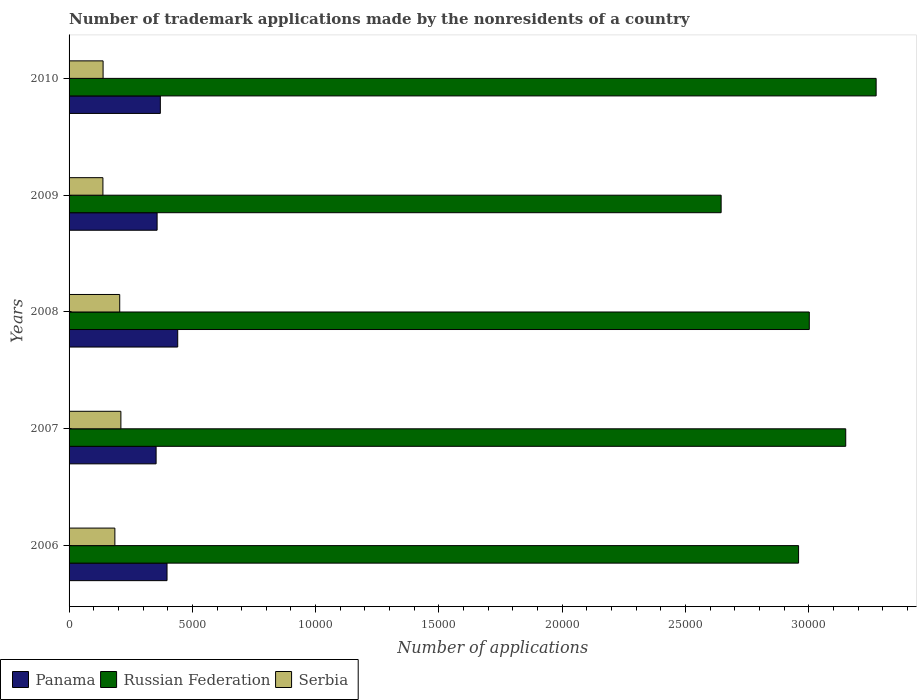Are the number of bars on each tick of the Y-axis equal?
Offer a terse response. Yes. How many bars are there on the 2nd tick from the bottom?
Give a very brief answer. 3. What is the label of the 4th group of bars from the top?
Your answer should be very brief. 2007. What is the number of trademark applications made by the nonresidents in Serbia in 2006?
Provide a succinct answer. 1858. Across all years, what is the maximum number of trademark applications made by the nonresidents in Panama?
Your response must be concise. 4407. Across all years, what is the minimum number of trademark applications made by the nonresidents in Russian Federation?
Offer a terse response. 2.64e+04. What is the total number of trademark applications made by the nonresidents in Panama in the graph?
Give a very brief answer. 1.92e+04. What is the difference between the number of trademark applications made by the nonresidents in Panama in 2007 and that in 2009?
Your answer should be very brief. -41. What is the difference between the number of trademark applications made by the nonresidents in Panama in 2009 and the number of trademark applications made by the nonresidents in Russian Federation in 2007?
Ensure brevity in your answer.  -2.79e+04. What is the average number of trademark applications made by the nonresidents in Serbia per year?
Your response must be concise. 1753.4. In the year 2010, what is the difference between the number of trademark applications made by the nonresidents in Russian Federation and number of trademark applications made by the nonresidents in Panama?
Your answer should be compact. 2.90e+04. In how many years, is the number of trademark applications made by the nonresidents in Panama greater than 5000 ?
Ensure brevity in your answer.  0. What is the ratio of the number of trademark applications made by the nonresidents in Russian Federation in 2006 to that in 2007?
Keep it short and to the point. 0.94. What is the difference between the highest and the second highest number of trademark applications made by the nonresidents in Panama?
Ensure brevity in your answer.  434. What is the difference between the highest and the lowest number of trademark applications made by the nonresidents in Panama?
Ensure brevity in your answer.  877. In how many years, is the number of trademark applications made by the nonresidents in Russian Federation greater than the average number of trademark applications made by the nonresidents in Russian Federation taken over all years?
Your response must be concise. 2. What does the 2nd bar from the top in 2006 represents?
Offer a very short reply. Russian Federation. What does the 1st bar from the bottom in 2009 represents?
Give a very brief answer. Panama. Is it the case that in every year, the sum of the number of trademark applications made by the nonresidents in Russian Federation and number of trademark applications made by the nonresidents in Serbia is greater than the number of trademark applications made by the nonresidents in Panama?
Your answer should be very brief. Yes. How many bars are there?
Provide a succinct answer. 15. Are all the bars in the graph horizontal?
Ensure brevity in your answer.  Yes. Does the graph contain grids?
Your response must be concise. No. Where does the legend appear in the graph?
Your response must be concise. Bottom left. How many legend labels are there?
Keep it short and to the point. 3. How are the legend labels stacked?
Your response must be concise. Horizontal. What is the title of the graph?
Your response must be concise. Number of trademark applications made by the nonresidents of a country. What is the label or title of the X-axis?
Provide a short and direct response. Number of applications. What is the Number of applications of Panama in 2006?
Your answer should be very brief. 3973. What is the Number of applications of Russian Federation in 2006?
Your answer should be very brief. 2.96e+04. What is the Number of applications of Serbia in 2006?
Keep it short and to the point. 1858. What is the Number of applications in Panama in 2007?
Offer a very short reply. 3530. What is the Number of applications of Russian Federation in 2007?
Your answer should be compact. 3.15e+04. What is the Number of applications in Serbia in 2007?
Your answer should be very brief. 2102. What is the Number of applications in Panama in 2008?
Provide a short and direct response. 4407. What is the Number of applications of Russian Federation in 2008?
Keep it short and to the point. 3.00e+04. What is the Number of applications in Serbia in 2008?
Your response must be concise. 2054. What is the Number of applications in Panama in 2009?
Provide a succinct answer. 3571. What is the Number of applications in Russian Federation in 2009?
Provide a short and direct response. 2.64e+04. What is the Number of applications in Serbia in 2009?
Your response must be concise. 1373. What is the Number of applications of Panama in 2010?
Your answer should be compact. 3702. What is the Number of applications of Russian Federation in 2010?
Offer a terse response. 3.27e+04. What is the Number of applications of Serbia in 2010?
Offer a terse response. 1380. Across all years, what is the maximum Number of applications of Panama?
Provide a succinct answer. 4407. Across all years, what is the maximum Number of applications of Russian Federation?
Provide a succinct answer. 3.27e+04. Across all years, what is the maximum Number of applications of Serbia?
Your answer should be very brief. 2102. Across all years, what is the minimum Number of applications in Panama?
Give a very brief answer. 3530. Across all years, what is the minimum Number of applications in Russian Federation?
Offer a very short reply. 2.64e+04. Across all years, what is the minimum Number of applications of Serbia?
Provide a succinct answer. 1373. What is the total Number of applications of Panama in the graph?
Your answer should be compact. 1.92e+04. What is the total Number of applications of Russian Federation in the graph?
Your response must be concise. 1.50e+05. What is the total Number of applications of Serbia in the graph?
Provide a short and direct response. 8767. What is the difference between the Number of applications in Panama in 2006 and that in 2007?
Give a very brief answer. 443. What is the difference between the Number of applications of Russian Federation in 2006 and that in 2007?
Provide a short and direct response. -1913. What is the difference between the Number of applications in Serbia in 2006 and that in 2007?
Your answer should be compact. -244. What is the difference between the Number of applications in Panama in 2006 and that in 2008?
Keep it short and to the point. -434. What is the difference between the Number of applications in Russian Federation in 2006 and that in 2008?
Your answer should be compact. -435. What is the difference between the Number of applications of Serbia in 2006 and that in 2008?
Your answer should be very brief. -196. What is the difference between the Number of applications of Panama in 2006 and that in 2009?
Keep it short and to the point. 402. What is the difference between the Number of applications of Russian Federation in 2006 and that in 2009?
Keep it short and to the point. 3141. What is the difference between the Number of applications in Serbia in 2006 and that in 2009?
Provide a short and direct response. 485. What is the difference between the Number of applications in Panama in 2006 and that in 2010?
Give a very brief answer. 271. What is the difference between the Number of applications in Russian Federation in 2006 and that in 2010?
Your answer should be compact. -3146. What is the difference between the Number of applications of Serbia in 2006 and that in 2010?
Provide a succinct answer. 478. What is the difference between the Number of applications of Panama in 2007 and that in 2008?
Ensure brevity in your answer.  -877. What is the difference between the Number of applications of Russian Federation in 2007 and that in 2008?
Your answer should be compact. 1478. What is the difference between the Number of applications in Serbia in 2007 and that in 2008?
Make the answer very short. 48. What is the difference between the Number of applications in Panama in 2007 and that in 2009?
Make the answer very short. -41. What is the difference between the Number of applications in Russian Federation in 2007 and that in 2009?
Your answer should be very brief. 5054. What is the difference between the Number of applications of Serbia in 2007 and that in 2009?
Make the answer very short. 729. What is the difference between the Number of applications in Panama in 2007 and that in 2010?
Offer a very short reply. -172. What is the difference between the Number of applications in Russian Federation in 2007 and that in 2010?
Offer a terse response. -1233. What is the difference between the Number of applications of Serbia in 2007 and that in 2010?
Offer a very short reply. 722. What is the difference between the Number of applications of Panama in 2008 and that in 2009?
Make the answer very short. 836. What is the difference between the Number of applications of Russian Federation in 2008 and that in 2009?
Offer a very short reply. 3576. What is the difference between the Number of applications in Serbia in 2008 and that in 2009?
Ensure brevity in your answer.  681. What is the difference between the Number of applications in Panama in 2008 and that in 2010?
Your answer should be compact. 705. What is the difference between the Number of applications in Russian Federation in 2008 and that in 2010?
Ensure brevity in your answer.  -2711. What is the difference between the Number of applications of Serbia in 2008 and that in 2010?
Make the answer very short. 674. What is the difference between the Number of applications of Panama in 2009 and that in 2010?
Your answer should be very brief. -131. What is the difference between the Number of applications of Russian Federation in 2009 and that in 2010?
Offer a very short reply. -6287. What is the difference between the Number of applications of Panama in 2006 and the Number of applications of Russian Federation in 2007?
Offer a terse response. -2.75e+04. What is the difference between the Number of applications of Panama in 2006 and the Number of applications of Serbia in 2007?
Offer a very short reply. 1871. What is the difference between the Number of applications in Russian Federation in 2006 and the Number of applications in Serbia in 2007?
Keep it short and to the point. 2.75e+04. What is the difference between the Number of applications of Panama in 2006 and the Number of applications of Russian Federation in 2008?
Provide a succinct answer. -2.61e+04. What is the difference between the Number of applications in Panama in 2006 and the Number of applications in Serbia in 2008?
Make the answer very short. 1919. What is the difference between the Number of applications in Russian Federation in 2006 and the Number of applications in Serbia in 2008?
Provide a succinct answer. 2.75e+04. What is the difference between the Number of applications in Panama in 2006 and the Number of applications in Russian Federation in 2009?
Keep it short and to the point. -2.25e+04. What is the difference between the Number of applications in Panama in 2006 and the Number of applications in Serbia in 2009?
Keep it short and to the point. 2600. What is the difference between the Number of applications of Russian Federation in 2006 and the Number of applications of Serbia in 2009?
Your answer should be very brief. 2.82e+04. What is the difference between the Number of applications in Panama in 2006 and the Number of applications in Russian Federation in 2010?
Keep it short and to the point. -2.88e+04. What is the difference between the Number of applications in Panama in 2006 and the Number of applications in Serbia in 2010?
Offer a terse response. 2593. What is the difference between the Number of applications in Russian Federation in 2006 and the Number of applications in Serbia in 2010?
Offer a terse response. 2.82e+04. What is the difference between the Number of applications of Panama in 2007 and the Number of applications of Russian Federation in 2008?
Provide a succinct answer. -2.65e+04. What is the difference between the Number of applications of Panama in 2007 and the Number of applications of Serbia in 2008?
Offer a terse response. 1476. What is the difference between the Number of applications of Russian Federation in 2007 and the Number of applications of Serbia in 2008?
Your response must be concise. 2.94e+04. What is the difference between the Number of applications in Panama in 2007 and the Number of applications in Russian Federation in 2009?
Give a very brief answer. -2.29e+04. What is the difference between the Number of applications of Panama in 2007 and the Number of applications of Serbia in 2009?
Your response must be concise. 2157. What is the difference between the Number of applications in Russian Federation in 2007 and the Number of applications in Serbia in 2009?
Offer a terse response. 3.01e+04. What is the difference between the Number of applications of Panama in 2007 and the Number of applications of Russian Federation in 2010?
Ensure brevity in your answer.  -2.92e+04. What is the difference between the Number of applications of Panama in 2007 and the Number of applications of Serbia in 2010?
Provide a short and direct response. 2150. What is the difference between the Number of applications in Russian Federation in 2007 and the Number of applications in Serbia in 2010?
Your answer should be very brief. 3.01e+04. What is the difference between the Number of applications of Panama in 2008 and the Number of applications of Russian Federation in 2009?
Keep it short and to the point. -2.20e+04. What is the difference between the Number of applications in Panama in 2008 and the Number of applications in Serbia in 2009?
Provide a succinct answer. 3034. What is the difference between the Number of applications of Russian Federation in 2008 and the Number of applications of Serbia in 2009?
Your response must be concise. 2.87e+04. What is the difference between the Number of applications of Panama in 2008 and the Number of applications of Russian Federation in 2010?
Offer a terse response. -2.83e+04. What is the difference between the Number of applications of Panama in 2008 and the Number of applications of Serbia in 2010?
Your response must be concise. 3027. What is the difference between the Number of applications of Russian Federation in 2008 and the Number of applications of Serbia in 2010?
Ensure brevity in your answer.  2.86e+04. What is the difference between the Number of applications of Panama in 2009 and the Number of applications of Russian Federation in 2010?
Keep it short and to the point. -2.92e+04. What is the difference between the Number of applications of Panama in 2009 and the Number of applications of Serbia in 2010?
Give a very brief answer. 2191. What is the difference between the Number of applications in Russian Federation in 2009 and the Number of applications in Serbia in 2010?
Offer a terse response. 2.51e+04. What is the average Number of applications in Panama per year?
Make the answer very short. 3836.6. What is the average Number of applications in Russian Federation per year?
Provide a short and direct response. 3.01e+04. What is the average Number of applications of Serbia per year?
Provide a short and direct response. 1753.4. In the year 2006, what is the difference between the Number of applications in Panama and Number of applications in Russian Federation?
Give a very brief answer. -2.56e+04. In the year 2006, what is the difference between the Number of applications of Panama and Number of applications of Serbia?
Keep it short and to the point. 2115. In the year 2006, what is the difference between the Number of applications of Russian Federation and Number of applications of Serbia?
Offer a very short reply. 2.77e+04. In the year 2007, what is the difference between the Number of applications in Panama and Number of applications in Russian Federation?
Give a very brief answer. -2.80e+04. In the year 2007, what is the difference between the Number of applications in Panama and Number of applications in Serbia?
Your response must be concise. 1428. In the year 2007, what is the difference between the Number of applications in Russian Federation and Number of applications in Serbia?
Provide a short and direct response. 2.94e+04. In the year 2008, what is the difference between the Number of applications in Panama and Number of applications in Russian Federation?
Your answer should be very brief. -2.56e+04. In the year 2008, what is the difference between the Number of applications in Panama and Number of applications in Serbia?
Offer a very short reply. 2353. In the year 2008, what is the difference between the Number of applications of Russian Federation and Number of applications of Serbia?
Your response must be concise. 2.80e+04. In the year 2009, what is the difference between the Number of applications of Panama and Number of applications of Russian Federation?
Your response must be concise. -2.29e+04. In the year 2009, what is the difference between the Number of applications of Panama and Number of applications of Serbia?
Make the answer very short. 2198. In the year 2009, what is the difference between the Number of applications of Russian Federation and Number of applications of Serbia?
Keep it short and to the point. 2.51e+04. In the year 2010, what is the difference between the Number of applications in Panama and Number of applications in Russian Federation?
Your response must be concise. -2.90e+04. In the year 2010, what is the difference between the Number of applications of Panama and Number of applications of Serbia?
Make the answer very short. 2322. In the year 2010, what is the difference between the Number of applications of Russian Federation and Number of applications of Serbia?
Keep it short and to the point. 3.14e+04. What is the ratio of the Number of applications of Panama in 2006 to that in 2007?
Offer a very short reply. 1.13. What is the ratio of the Number of applications in Russian Federation in 2006 to that in 2007?
Provide a short and direct response. 0.94. What is the ratio of the Number of applications in Serbia in 2006 to that in 2007?
Provide a succinct answer. 0.88. What is the ratio of the Number of applications of Panama in 2006 to that in 2008?
Ensure brevity in your answer.  0.9. What is the ratio of the Number of applications in Russian Federation in 2006 to that in 2008?
Your response must be concise. 0.99. What is the ratio of the Number of applications in Serbia in 2006 to that in 2008?
Your answer should be very brief. 0.9. What is the ratio of the Number of applications of Panama in 2006 to that in 2009?
Your answer should be compact. 1.11. What is the ratio of the Number of applications in Russian Federation in 2006 to that in 2009?
Keep it short and to the point. 1.12. What is the ratio of the Number of applications in Serbia in 2006 to that in 2009?
Provide a short and direct response. 1.35. What is the ratio of the Number of applications of Panama in 2006 to that in 2010?
Give a very brief answer. 1.07. What is the ratio of the Number of applications in Russian Federation in 2006 to that in 2010?
Offer a terse response. 0.9. What is the ratio of the Number of applications in Serbia in 2006 to that in 2010?
Ensure brevity in your answer.  1.35. What is the ratio of the Number of applications in Panama in 2007 to that in 2008?
Make the answer very short. 0.8. What is the ratio of the Number of applications in Russian Federation in 2007 to that in 2008?
Keep it short and to the point. 1.05. What is the ratio of the Number of applications of Serbia in 2007 to that in 2008?
Provide a short and direct response. 1.02. What is the ratio of the Number of applications in Russian Federation in 2007 to that in 2009?
Provide a short and direct response. 1.19. What is the ratio of the Number of applications in Serbia in 2007 to that in 2009?
Your answer should be compact. 1.53. What is the ratio of the Number of applications in Panama in 2007 to that in 2010?
Offer a very short reply. 0.95. What is the ratio of the Number of applications in Russian Federation in 2007 to that in 2010?
Offer a very short reply. 0.96. What is the ratio of the Number of applications in Serbia in 2007 to that in 2010?
Ensure brevity in your answer.  1.52. What is the ratio of the Number of applications in Panama in 2008 to that in 2009?
Provide a succinct answer. 1.23. What is the ratio of the Number of applications in Russian Federation in 2008 to that in 2009?
Ensure brevity in your answer.  1.14. What is the ratio of the Number of applications of Serbia in 2008 to that in 2009?
Your answer should be very brief. 1.5. What is the ratio of the Number of applications of Panama in 2008 to that in 2010?
Give a very brief answer. 1.19. What is the ratio of the Number of applications in Russian Federation in 2008 to that in 2010?
Offer a terse response. 0.92. What is the ratio of the Number of applications of Serbia in 2008 to that in 2010?
Your answer should be compact. 1.49. What is the ratio of the Number of applications in Panama in 2009 to that in 2010?
Your answer should be very brief. 0.96. What is the ratio of the Number of applications in Russian Federation in 2009 to that in 2010?
Offer a very short reply. 0.81. What is the ratio of the Number of applications of Serbia in 2009 to that in 2010?
Your answer should be compact. 0.99. What is the difference between the highest and the second highest Number of applications of Panama?
Make the answer very short. 434. What is the difference between the highest and the second highest Number of applications in Russian Federation?
Offer a terse response. 1233. What is the difference between the highest and the lowest Number of applications in Panama?
Provide a short and direct response. 877. What is the difference between the highest and the lowest Number of applications in Russian Federation?
Provide a short and direct response. 6287. What is the difference between the highest and the lowest Number of applications of Serbia?
Your response must be concise. 729. 